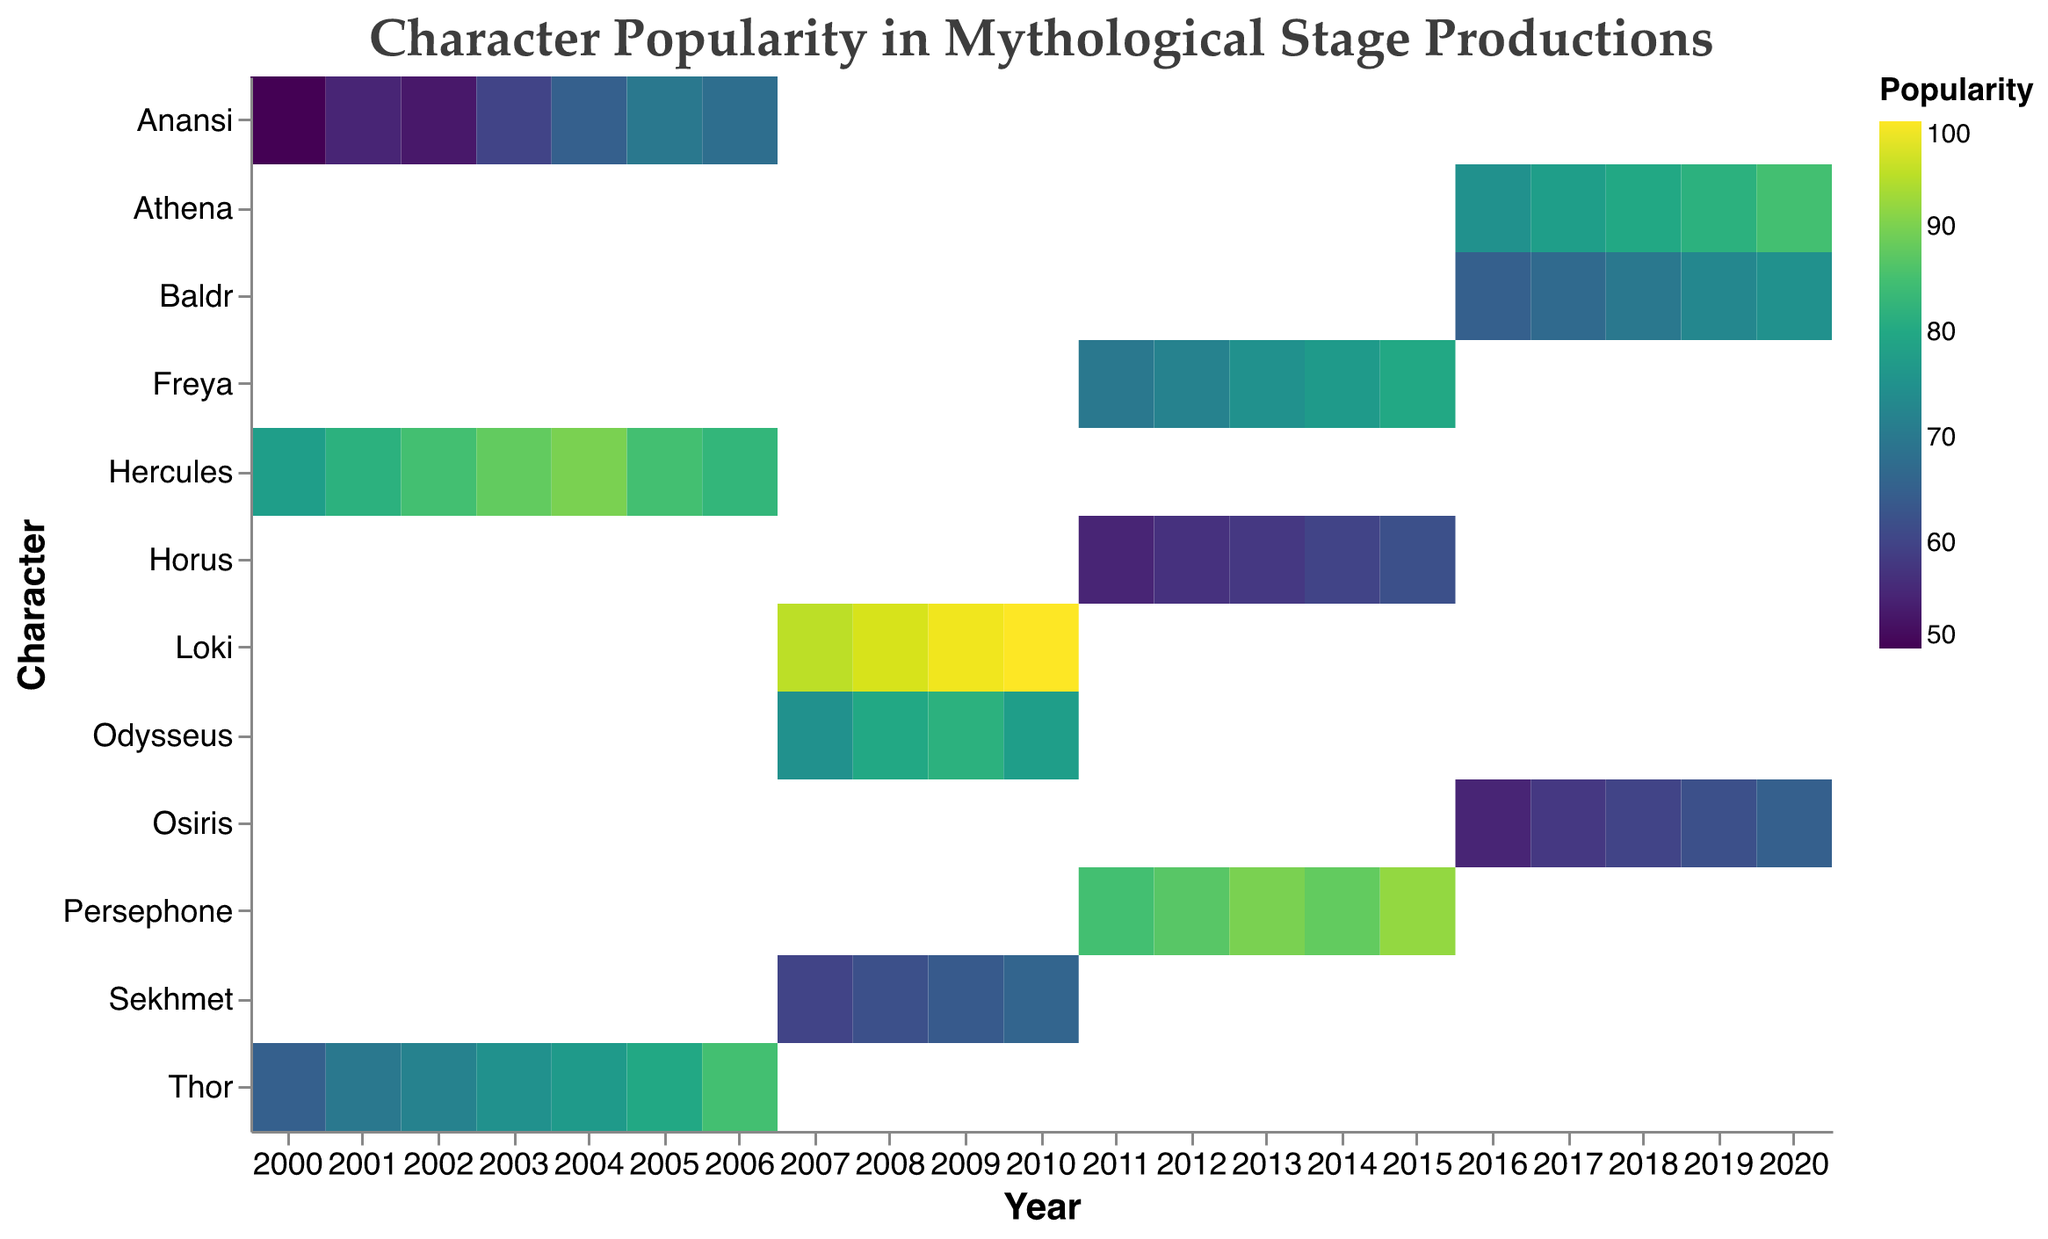What is the title of the heatmap? The title of the heatmap is displayed at the top and provides a clear description of what the visualization represents.
Answer: "Character Popularity in Mythological Stage Productions" Which character has the highest recorded popularity score and in what year? By looking at the color intensity of the heatmap, the character with the highest popularity score can be identified. The tooltip on the darkest cell shows that Loki has the highest score.
Answer: Loki in 2010 How does the popularity of Hercules change from 2000 to 2006? Observe the cells corresponding to Hercules from 2000 to 2006. The colors get progressively darker, indicating increasing popularity, up to 2004, and then slightly decrease.
Answer: Increases from 78 to 90, then decreases to 83 Between 2007 and 2009, which mythology has the most popular characters in total? Compare the popularity scores of characters from different mythologies across these years, summing up the scores for Greek, Norse, and Egyptian mythologies respectively.
Answer: Norse What is the average popularity of Athena from 2016 to 2020? Sum the popularity scores of Athena from 2016 to 2020 and divide by the number of years (5).
Answer: (75 + 78 + 80 + 82 + 85) / 5 = 80 Compare the popularity of Greek and Norse mythological characters in 2011. Which mythology is more popular on average this year? Sum the popularity scores for the Greek characters and the Norse characters in 2011 and divide by the number of characters in each mythology to find the average.
Answer: Greek: 85; Norse: 70; Greek is more popular Which year shows the introduction of the characters Persephone, Freya, and Horus in the heatmap? Identify the cells for Persephone, Freya, and Horus. The first year they appear in the visualization is their introduction year.
Answer: 2011 In which year does Anansi experience the highest popularity? Track the cells corresponding to Anansi over the years and identify the year with the darkest cell color.
Answer: 2005 What trend is observed in the popularity of Osiris from 2016 to 2020? Follow the progression of the cell color from 2016 to 2020 for Osiris to see the trend. The colors get progressively darker, indicating increasing popularity.
Answer: Increasing trend Compare the popularity of Loki in 2007 and Thor in 2006. Which character was more popular in their respective years? Locate the cells for Loki in 2007 and Thor in 2006, and compare their popularity scores shown in the heatmap.
Answer: Loki in 2007 